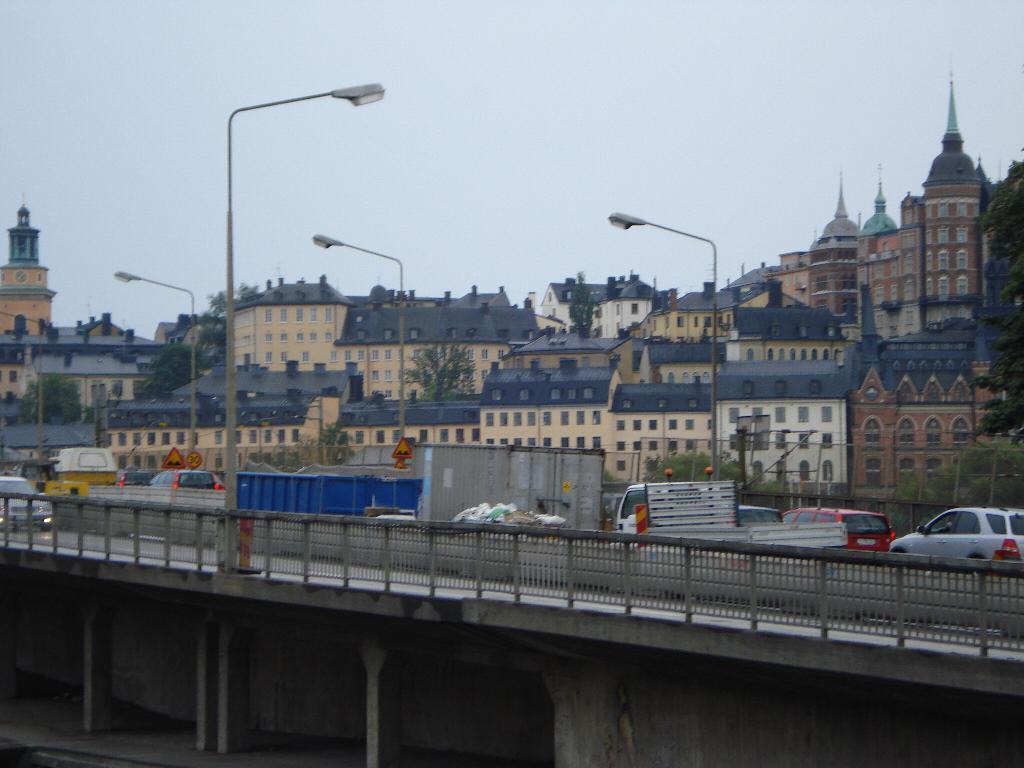Can you describe this image briefly? We can see bridge, fence, vehicles, lights and boards on poles. In the background we can see buildings, trees and sky. 